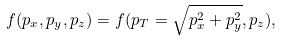<formula> <loc_0><loc_0><loc_500><loc_500>f ( p _ { x } , p _ { y } , p _ { z } ) = f ( p _ { T } = \sqrt { p _ { x } ^ { 2 } + p _ { y } ^ { 2 } } , p _ { z } ) ,</formula> 